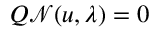Convert formula to latex. <formula><loc_0><loc_0><loc_500><loc_500>Q \mathcal { N } ( u , \lambda ) = 0</formula> 